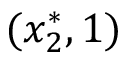<formula> <loc_0><loc_0><loc_500><loc_500>( x _ { 2 } ^ { * } , 1 )</formula> 